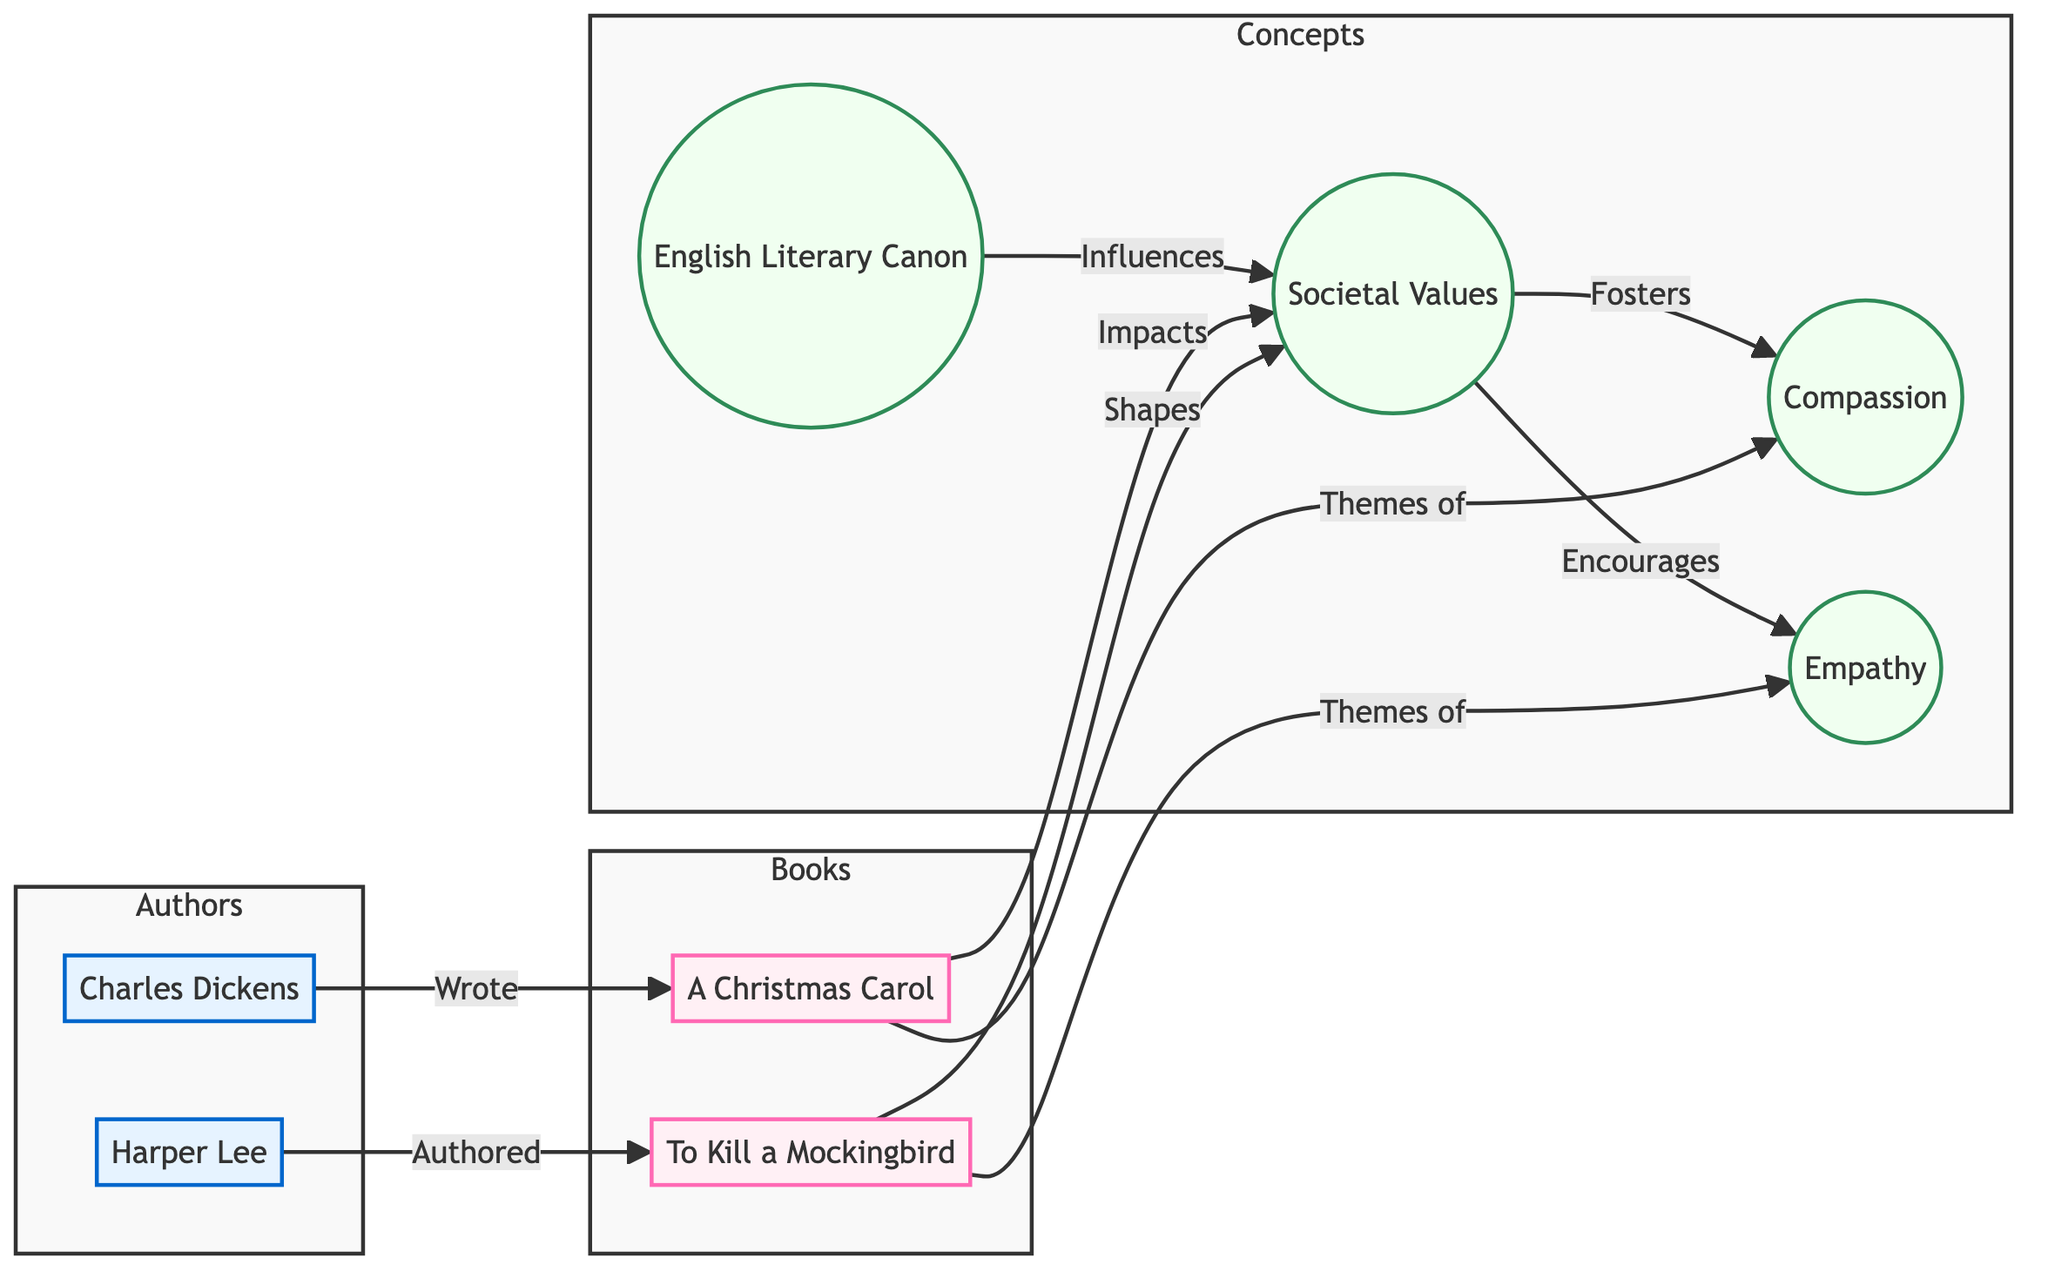What is the primary influence on societal values in this diagram? The diagram shows that the English Literary Canon directly influences societal values, establishing it as the core element leading to changes in these values.
Answer: English Literary Canon How many authors are represented in the diagram? There are two distinct authors depicted in the diagram, namely Charles Dickens and Harper Lee.
Answer: 2 What theme is associated with 'A Christmas Carol'? According to the diagram, 'A Christmas Carol' is associated with the theme of compassion which is explicitly mentioned in its connection.
Answer: compassion Which book is linked to the theme of empathy? The diagram indicates that 'To Kill a Mockingbird' is the book linked to the theme of empathy, highlighting its specific relevance in the representation.
Answer: To Kill a Mockingbird What role does 'To Kill a Mockingbird' play in societal values? The diagram illustrates that 'To Kill a Mockingbird' shapes societal values, indicating its influence on how society perceives various ideals.
Answer: Shapes How many types of concepts are identified in the diagram? The diagram identifies four types of concepts: the English Literary Canon, societal values, compassion, and empathy; thus, totaling four distinct concepts.
Answer: 4 What are the two main values fostered by societal values? From the diagram, the two main values fostered by societal values are compassion and empathy, clearly stated in their connections.
Answer: compassion and empathy Which author wrote 'A Christmas Carol'? The diagram specifies that Charles Dickens is the author of 'A Christmas Carol,' establishing a direct authorship link.
Answer: Charles Dickens How do the themes of the two books influence societal values? Both 'A Christmas Carol' and 'To Kill a Mockingbird' impact societal values by introducing themes that encourage a deeper understanding and awareness of compassion and empathy, respectively. This demonstrates a collective shaping of values through literature.
Answer: Impacts and Shapes 